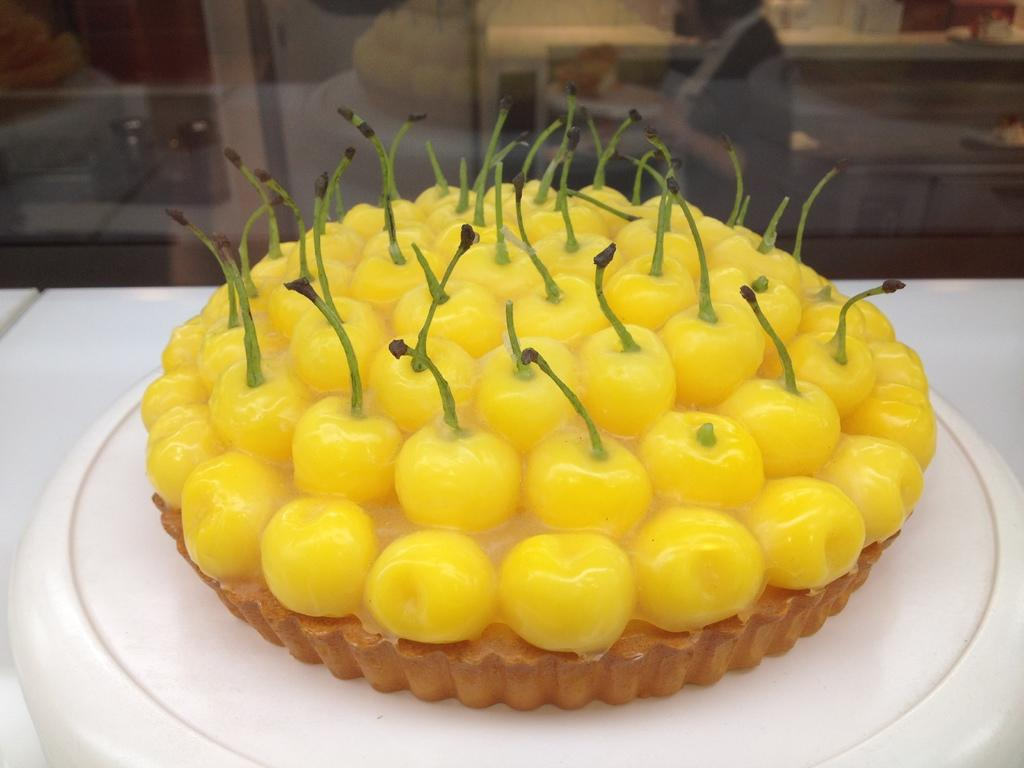What is the primary object on the table in the image? There is food placed on a table in the image. What is the color of the table? The table is white. What is the color of the food on the table? The food is yellow. Can you describe the person visible in the background of the image? Unfortunately, the provided facts do not give enough information to describe the person in the background. What type of button is being used to control the heart rate of the person in the image? There is no button or mention of a person's heart rate in the image. 